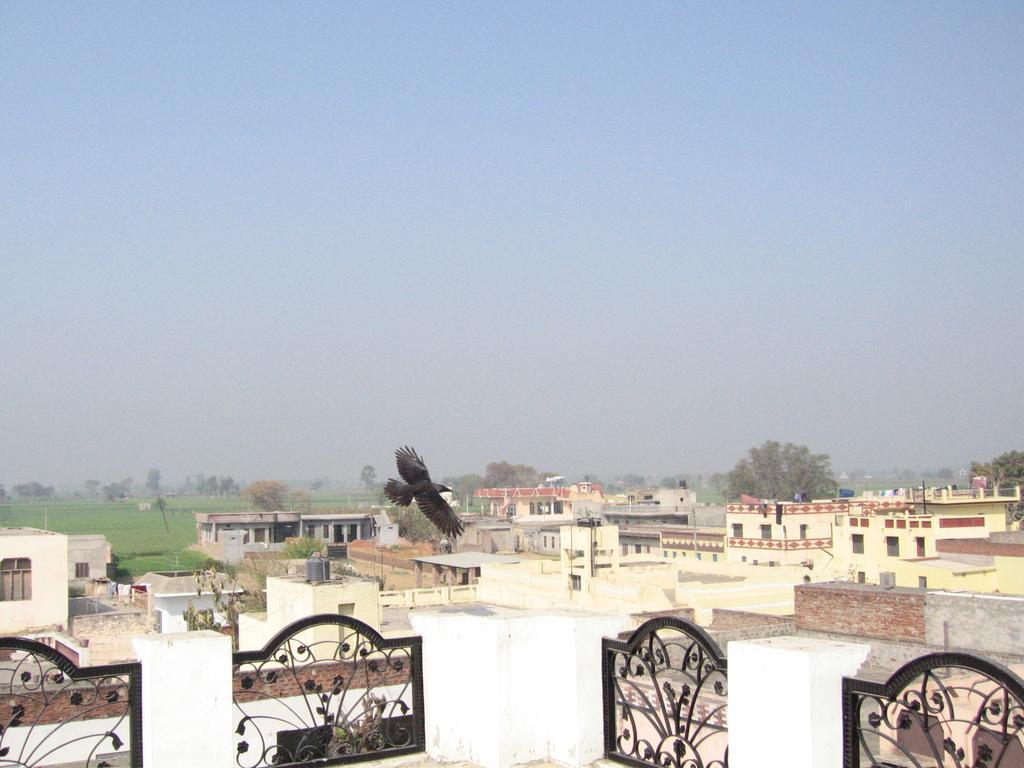In one or two sentences, can you explain what this image depicts? In the center of the image, we can see a bird flying and at the bottom, there are buildings, trees, tanks, railings, poles and we can see clothes hanging and there are fields. At the top, there is sky. 